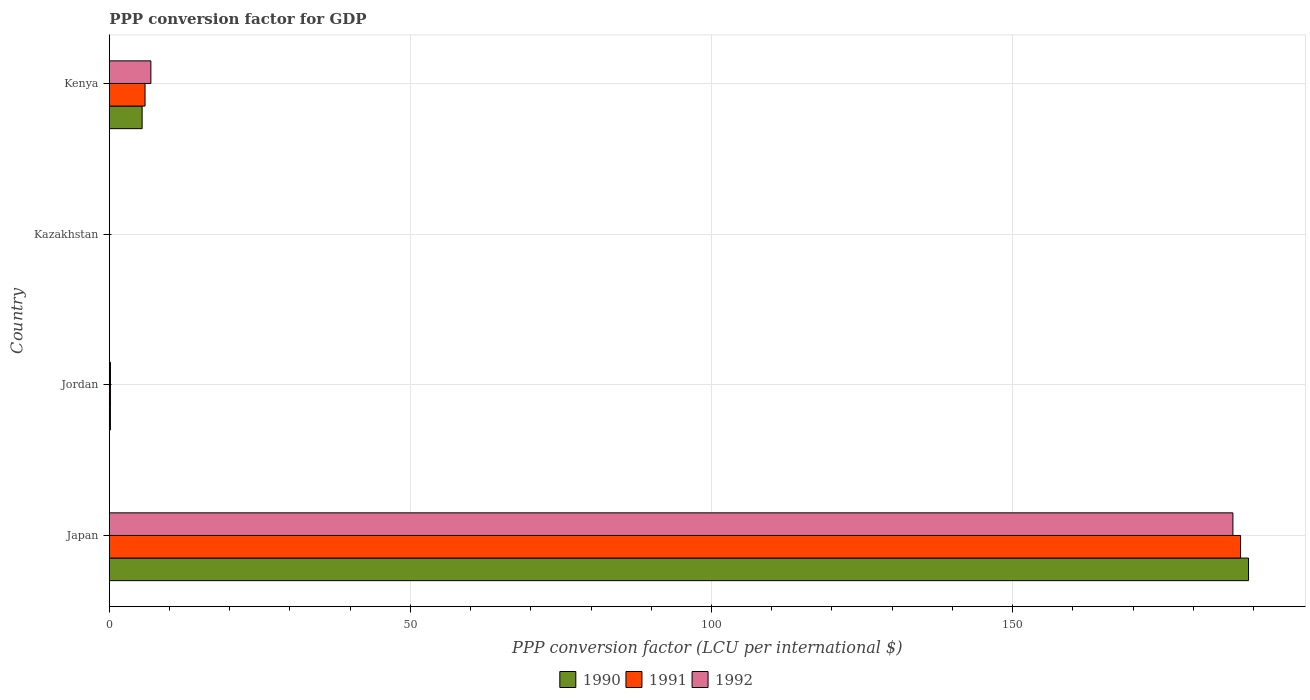Are the number of bars on each tick of the Y-axis equal?
Offer a very short reply. Yes. How many bars are there on the 2nd tick from the top?
Your answer should be compact. 3. What is the label of the 1st group of bars from the top?
Make the answer very short. Kenya. What is the PPP conversion factor for GDP in 1991 in Kazakhstan?
Provide a succinct answer. 0. Across all countries, what is the maximum PPP conversion factor for GDP in 1990?
Offer a terse response. 189.17. Across all countries, what is the minimum PPP conversion factor for GDP in 1991?
Keep it short and to the point. 0. In which country was the PPP conversion factor for GDP in 1991 minimum?
Offer a terse response. Kazakhstan. What is the total PPP conversion factor for GDP in 1990 in the graph?
Provide a short and direct response. 194.82. What is the difference between the PPP conversion factor for GDP in 1991 in Jordan and that in Kazakhstan?
Your answer should be very brief. 0.19. What is the difference between the PPP conversion factor for GDP in 1990 in Jordan and the PPP conversion factor for GDP in 1992 in Japan?
Offer a terse response. -186.39. What is the average PPP conversion factor for GDP in 1991 per country?
Provide a succinct answer. 48.5. What is the difference between the PPP conversion factor for GDP in 1991 and PPP conversion factor for GDP in 1992 in Jordan?
Offer a terse response. -0. What is the ratio of the PPP conversion factor for GDP in 1991 in Japan to that in Kenya?
Offer a terse response. 31.62. Is the difference between the PPP conversion factor for GDP in 1991 in Kazakhstan and Kenya greater than the difference between the PPP conversion factor for GDP in 1992 in Kazakhstan and Kenya?
Give a very brief answer. Yes. What is the difference between the highest and the second highest PPP conversion factor for GDP in 1990?
Your answer should be very brief. 183.72. What is the difference between the highest and the lowest PPP conversion factor for GDP in 1991?
Make the answer very short. 187.85. In how many countries, is the PPP conversion factor for GDP in 1991 greater than the average PPP conversion factor for GDP in 1991 taken over all countries?
Your answer should be compact. 1. Is the sum of the PPP conversion factor for GDP in 1992 in Kazakhstan and Kenya greater than the maximum PPP conversion factor for GDP in 1990 across all countries?
Your answer should be very brief. No. What does the 2nd bar from the top in Kazakhstan represents?
Offer a very short reply. 1991. What is the difference between two consecutive major ticks on the X-axis?
Offer a very short reply. 50. Are the values on the major ticks of X-axis written in scientific E-notation?
Provide a short and direct response. No. Where does the legend appear in the graph?
Offer a very short reply. Bottom center. What is the title of the graph?
Provide a short and direct response. PPP conversion factor for GDP. Does "2015" appear as one of the legend labels in the graph?
Make the answer very short. No. What is the label or title of the X-axis?
Offer a very short reply. PPP conversion factor (LCU per international $). What is the label or title of the Y-axis?
Offer a very short reply. Country. What is the PPP conversion factor (LCU per international $) of 1990 in Japan?
Your answer should be compact. 189.17. What is the PPP conversion factor (LCU per international $) of 1991 in Japan?
Ensure brevity in your answer.  187.85. What is the PPP conversion factor (LCU per international $) in 1992 in Japan?
Your answer should be compact. 186.58. What is the PPP conversion factor (LCU per international $) in 1990 in Jordan?
Give a very brief answer. 0.19. What is the PPP conversion factor (LCU per international $) in 1991 in Jordan?
Your answer should be very brief. 0.19. What is the PPP conversion factor (LCU per international $) of 1992 in Jordan?
Your answer should be very brief. 0.2. What is the PPP conversion factor (LCU per international $) in 1990 in Kazakhstan?
Your answer should be very brief. 0. What is the PPP conversion factor (LCU per international $) in 1991 in Kazakhstan?
Give a very brief answer. 0. What is the PPP conversion factor (LCU per international $) of 1992 in Kazakhstan?
Provide a succinct answer. 0.02. What is the PPP conversion factor (LCU per international $) of 1990 in Kenya?
Ensure brevity in your answer.  5.46. What is the PPP conversion factor (LCU per international $) of 1991 in Kenya?
Offer a terse response. 5.94. What is the PPP conversion factor (LCU per international $) in 1992 in Kenya?
Your answer should be very brief. 6.91. Across all countries, what is the maximum PPP conversion factor (LCU per international $) of 1990?
Your answer should be very brief. 189.17. Across all countries, what is the maximum PPP conversion factor (LCU per international $) in 1991?
Offer a very short reply. 187.85. Across all countries, what is the maximum PPP conversion factor (LCU per international $) in 1992?
Your answer should be compact. 186.58. Across all countries, what is the minimum PPP conversion factor (LCU per international $) in 1990?
Ensure brevity in your answer.  0. Across all countries, what is the minimum PPP conversion factor (LCU per international $) of 1991?
Make the answer very short. 0. Across all countries, what is the minimum PPP conversion factor (LCU per international $) in 1992?
Give a very brief answer. 0.02. What is the total PPP conversion factor (LCU per international $) in 1990 in the graph?
Ensure brevity in your answer.  194.82. What is the total PPP conversion factor (LCU per international $) in 1991 in the graph?
Provide a succinct answer. 193.99. What is the total PPP conversion factor (LCU per international $) of 1992 in the graph?
Your response must be concise. 193.7. What is the difference between the PPP conversion factor (LCU per international $) in 1990 in Japan and that in Jordan?
Your response must be concise. 188.98. What is the difference between the PPP conversion factor (LCU per international $) in 1991 in Japan and that in Jordan?
Your answer should be very brief. 187.65. What is the difference between the PPP conversion factor (LCU per international $) in 1992 in Japan and that in Jordan?
Ensure brevity in your answer.  186.38. What is the difference between the PPP conversion factor (LCU per international $) in 1990 in Japan and that in Kazakhstan?
Keep it short and to the point. 189.17. What is the difference between the PPP conversion factor (LCU per international $) of 1991 in Japan and that in Kazakhstan?
Your answer should be very brief. 187.85. What is the difference between the PPP conversion factor (LCU per international $) of 1992 in Japan and that in Kazakhstan?
Provide a short and direct response. 186.56. What is the difference between the PPP conversion factor (LCU per international $) in 1990 in Japan and that in Kenya?
Offer a very short reply. 183.72. What is the difference between the PPP conversion factor (LCU per international $) in 1991 in Japan and that in Kenya?
Make the answer very short. 181.91. What is the difference between the PPP conversion factor (LCU per international $) in 1992 in Japan and that in Kenya?
Provide a short and direct response. 179.67. What is the difference between the PPP conversion factor (LCU per international $) in 1990 in Jordan and that in Kazakhstan?
Keep it short and to the point. 0.19. What is the difference between the PPP conversion factor (LCU per international $) of 1991 in Jordan and that in Kazakhstan?
Give a very brief answer. 0.19. What is the difference between the PPP conversion factor (LCU per international $) in 1992 in Jordan and that in Kazakhstan?
Your response must be concise. 0.18. What is the difference between the PPP conversion factor (LCU per international $) of 1990 in Jordan and that in Kenya?
Make the answer very short. -5.26. What is the difference between the PPP conversion factor (LCU per international $) of 1991 in Jordan and that in Kenya?
Keep it short and to the point. -5.75. What is the difference between the PPP conversion factor (LCU per international $) of 1992 in Jordan and that in Kenya?
Your response must be concise. -6.71. What is the difference between the PPP conversion factor (LCU per international $) of 1990 in Kazakhstan and that in Kenya?
Your answer should be compact. -5.45. What is the difference between the PPP conversion factor (LCU per international $) of 1991 in Kazakhstan and that in Kenya?
Your answer should be compact. -5.94. What is the difference between the PPP conversion factor (LCU per international $) of 1992 in Kazakhstan and that in Kenya?
Make the answer very short. -6.89. What is the difference between the PPP conversion factor (LCU per international $) in 1990 in Japan and the PPP conversion factor (LCU per international $) in 1991 in Jordan?
Offer a terse response. 188.98. What is the difference between the PPP conversion factor (LCU per international $) of 1990 in Japan and the PPP conversion factor (LCU per international $) of 1992 in Jordan?
Your answer should be compact. 188.98. What is the difference between the PPP conversion factor (LCU per international $) of 1991 in Japan and the PPP conversion factor (LCU per international $) of 1992 in Jordan?
Your answer should be very brief. 187.65. What is the difference between the PPP conversion factor (LCU per international $) in 1990 in Japan and the PPP conversion factor (LCU per international $) in 1991 in Kazakhstan?
Give a very brief answer. 189.17. What is the difference between the PPP conversion factor (LCU per international $) in 1990 in Japan and the PPP conversion factor (LCU per international $) in 1992 in Kazakhstan?
Your response must be concise. 189.15. What is the difference between the PPP conversion factor (LCU per international $) in 1991 in Japan and the PPP conversion factor (LCU per international $) in 1992 in Kazakhstan?
Offer a very short reply. 187.83. What is the difference between the PPP conversion factor (LCU per international $) of 1990 in Japan and the PPP conversion factor (LCU per international $) of 1991 in Kenya?
Offer a terse response. 183.23. What is the difference between the PPP conversion factor (LCU per international $) of 1990 in Japan and the PPP conversion factor (LCU per international $) of 1992 in Kenya?
Your response must be concise. 182.27. What is the difference between the PPP conversion factor (LCU per international $) of 1991 in Japan and the PPP conversion factor (LCU per international $) of 1992 in Kenya?
Provide a short and direct response. 180.94. What is the difference between the PPP conversion factor (LCU per international $) of 1990 in Jordan and the PPP conversion factor (LCU per international $) of 1991 in Kazakhstan?
Ensure brevity in your answer.  0.19. What is the difference between the PPP conversion factor (LCU per international $) of 1990 in Jordan and the PPP conversion factor (LCU per international $) of 1992 in Kazakhstan?
Make the answer very short. 0.17. What is the difference between the PPP conversion factor (LCU per international $) of 1991 in Jordan and the PPP conversion factor (LCU per international $) of 1992 in Kazakhstan?
Provide a succinct answer. 0.17. What is the difference between the PPP conversion factor (LCU per international $) of 1990 in Jordan and the PPP conversion factor (LCU per international $) of 1991 in Kenya?
Provide a short and direct response. -5.75. What is the difference between the PPP conversion factor (LCU per international $) of 1990 in Jordan and the PPP conversion factor (LCU per international $) of 1992 in Kenya?
Keep it short and to the point. -6.72. What is the difference between the PPP conversion factor (LCU per international $) of 1991 in Jordan and the PPP conversion factor (LCU per international $) of 1992 in Kenya?
Give a very brief answer. -6.71. What is the difference between the PPP conversion factor (LCU per international $) of 1990 in Kazakhstan and the PPP conversion factor (LCU per international $) of 1991 in Kenya?
Give a very brief answer. -5.94. What is the difference between the PPP conversion factor (LCU per international $) in 1990 in Kazakhstan and the PPP conversion factor (LCU per international $) in 1992 in Kenya?
Provide a succinct answer. -6.91. What is the difference between the PPP conversion factor (LCU per international $) of 1991 in Kazakhstan and the PPP conversion factor (LCU per international $) of 1992 in Kenya?
Your answer should be very brief. -6.91. What is the average PPP conversion factor (LCU per international $) in 1990 per country?
Provide a succinct answer. 48.7. What is the average PPP conversion factor (LCU per international $) of 1991 per country?
Provide a succinct answer. 48.5. What is the average PPP conversion factor (LCU per international $) in 1992 per country?
Offer a very short reply. 48.43. What is the difference between the PPP conversion factor (LCU per international $) of 1990 and PPP conversion factor (LCU per international $) of 1991 in Japan?
Your response must be concise. 1.32. What is the difference between the PPP conversion factor (LCU per international $) of 1990 and PPP conversion factor (LCU per international $) of 1992 in Japan?
Provide a short and direct response. 2.59. What is the difference between the PPP conversion factor (LCU per international $) of 1991 and PPP conversion factor (LCU per international $) of 1992 in Japan?
Provide a short and direct response. 1.27. What is the difference between the PPP conversion factor (LCU per international $) of 1990 and PPP conversion factor (LCU per international $) of 1991 in Jordan?
Give a very brief answer. -0. What is the difference between the PPP conversion factor (LCU per international $) of 1990 and PPP conversion factor (LCU per international $) of 1992 in Jordan?
Keep it short and to the point. -0. What is the difference between the PPP conversion factor (LCU per international $) in 1991 and PPP conversion factor (LCU per international $) in 1992 in Jordan?
Your answer should be compact. -0. What is the difference between the PPP conversion factor (LCU per international $) of 1990 and PPP conversion factor (LCU per international $) of 1991 in Kazakhstan?
Keep it short and to the point. -0. What is the difference between the PPP conversion factor (LCU per international $) in 1990 and PPP conversion factor (LCU per international $) in 1992 in Kazakhstan?
Keep it short and to the point. -0.02. What is the difference between the PPP conversion factor (LCU per international $) of 1991 and PPP conversion factor (LCU per international $) of 1992 in Kazakhstan?
Provide a succinct answer. -0.02. What is the difference between the PPP conversion factor (LCU per international $) of 1990 and PPP conversion factor (LCU per international $) of 1991 in Kenya?
Your answer should be very brief. -0.49. What is the difference between the PPP conversion factor (LCU per international $) of 1990 and PPP conversion factor (LCU per international $) of 1992 in Kenya?
Give a very brief answer. -1.45. What is the difference between the PPP conversion factor (LCU per international $) of 1991 and PPP conversion factor (LCU per international $) of 1992 in Kenya?
Offer a terse response. -0.97. What is the ratio of the PPP conversion factor (LCU per international $) in 1990 in Japan to that in Jordan?
Offer a terse response. 990.73. What is the ratio of the PPP conversion factor (LCU per international $) of 1991 in Japan to that in Jordan?
Ensure brevity in your answer.  966.15. What is the ratio of the PPP conversion factor (LCU per international $) in 1992 in Japan to that in Jordan?
Give a very brief answer. 954.23. What is the ratio of the PPP conversion factor (LCU per international $) in 1990 in Japan to that in Kazakhstan?
Provide a succinct answer. 2.74e+05. What is the ratio of the PPP conversion factor (LCU per international $) in 1991 in Japan to that in Kazakhstan?
Your answer should be compact. 1.43e+05. What is the ratio of the PPP conversion factor (LCU per international $) in 1992 in Japan to that in Kazakhstan?
Your answer should be very brief. 9266.86. What is the ratio of the PPP conversion factor (LCU per international $) in 1990 in Japan to that in Kenya?
Provide a succinct answer. 34.67. What is the ratio of the PPP conversion factor (LCU per international $) of 1991 in Japan to that in Kenya?
Offer a very short reply. 31.62. What is the ratio of the PPP conversion factor (LCU per international $) of 1992 in Japan to that in Kenya?
Provide a succinct answer. 27.01. What is the ratio of the PPP conversion factor (LCU per international $) of 1990 in Jordan to that in Kazakhstan?
Provide a succinct answer. 277.03. What is the ratio of the PPP conversion factor (LCU per international $) in 1991 in Jordan to that in Kazakhstan?
Give a very brief answer. 148.44. What is the ratio of the PPP conversion factor (LCU per international $) of 1992 in Jordan to that in Kazakhstan?
Provide a short and direct response. 9.71. What is the ratio of the PPP conversion factor (LCU per international $) of 1990 in Jordan to that in Kenya?
Your answer should be compact. 0.04. What is the ratio of the PPP conversion factor (LCU per international $) in 1991 in Jordan to that in Kenya?
Offer a terse response. 0.03. What is the ratio of the PPP conversion factor (LCU per international $) in 1992 in Jordan to that in Kenya?
Offer a very short reply. 0.03. What is the ratio of the PPP conversion factor (LCU per international $) of 1992 in Kazakhstan to that in Kenya?
Make the answer very short. 0. What is the difference between the highest and the second highest PPP conversion factor (LCU per international $) of 1990?
Keep it short and to the point. 183.72. What is the difference between the highest and the second highest PPP conversion factor (LCU per international $) of 1991?
Offer a terse response. 181.91. What is the difference between the highest and the second highest PPP conversion factor (LCU per international $) of 1992?
Make the answer very short. 179.67. What is the difference between the highest and the lowest PPP conversion factor (LCU per international $) of 1990?
Provide a succinct answer. 189.17. What is the difference between the highest and the lowest PPP conversion factor (LCU per international $) in 1991?
Give a very brief answer. 187.85. What is the difference between the highest and the lowest PPP conversion factor (LCU per international $) in 1992?
Offer a very short reply. 186.56. 